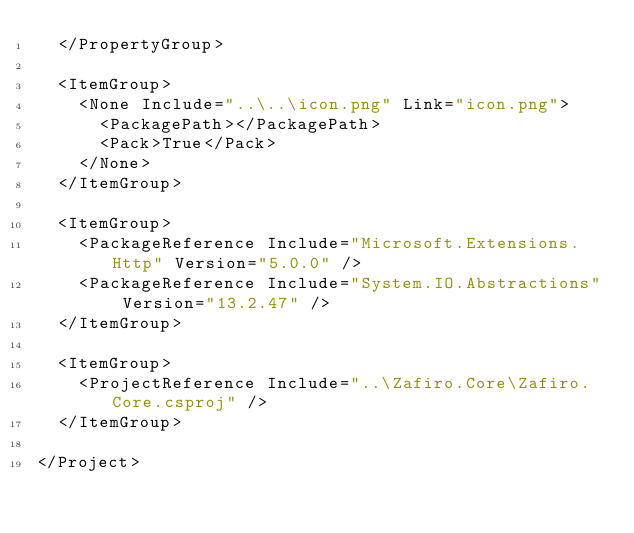Convert code to text. <code><loc_0><loc_0><loc_500><loc_500><_XML_>	</PropertyGroup>

	<ItemGroup>
	  <None Include="..\..\icon.png" Link="icon.png">
	    <PackagePath></PackagePath>
	    <Pack>True</Pack>
	  </None>
	</ItemGroup>

	<ItemGroup>
		<PackageReference Include="Microsoft.Extensions.Http" Version="5.0.0" />
		<PackageReference Include="System.IO.Abstractions" Version="13.2.47" />
	</ItemGroup>

	<ItemGroup>
		<ProjectReference Include="..\Zafiro.Core\Zafiro.Core.csproj" />
	</ItemGroup>

</Project>
</code> 